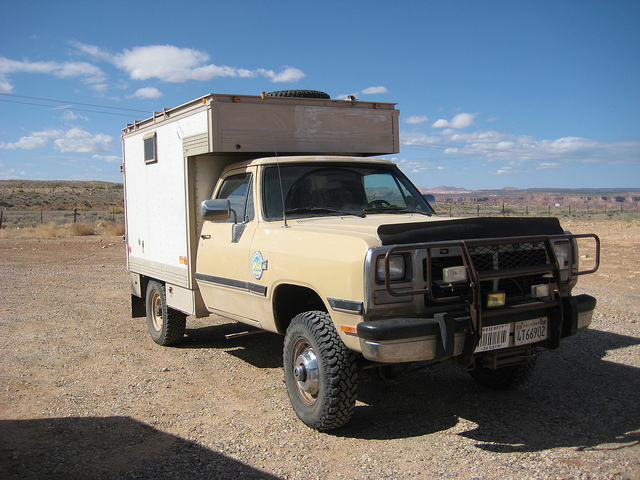<image>What words are on the car's bumper plate? It is unclear what words are on the car's bumper plate. It can be 'info', 'dodge', 't60502', 'california' or others. What words are on the car's bumper plate? I am not sure what words are on the car's bumper plate. It is unclear and unknown. 